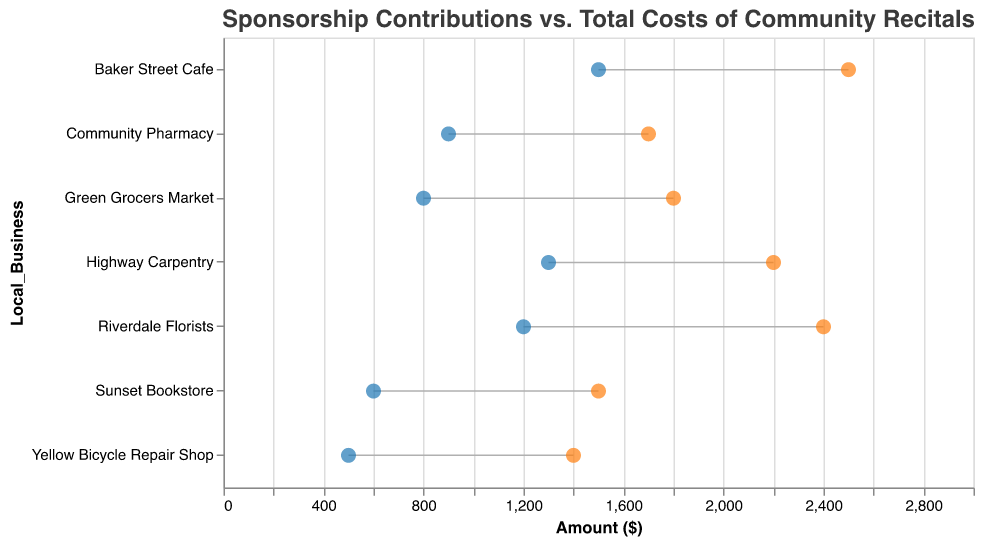What's the title of the figure? The title is displayed at the top of the plot to give an overview of what the plot represents. In this case, the title conveys information about the relationship between sponsorship contributions and total organizing costs for community recitals.
Answer: Sponsorship Contributions vs. Total Costs of Community Recitals Which local business has the highest sponsorship contribution? By looking at the dumbbell plot, we can identify the business with the highest position on the x-axis for sponsorship contributions. Baker Street Cafe has the highest contribution at $1500.
Answer: Baker Street Cafe Which local business has the smallest gap between sponsorship contribution and total cost of organizing? To find this, we look at the distance between the blue and orange circles (markers) for each local business. Riverdale Florists has the smallest gap, with a difference of $1200 and $2400, making the gap $1200.
Answer: Riverdale Florists What is the total cost of organizing recitals for the Community Pharmacy? The orange circle near "Community Pharmacy" shows its position on the x-axis for total costs. The value is $1700.
Answer: $1700 How much more is the total cost of organizing for Green Grocers Market compared to its sponsorship contribution? We need to subtract the sponsorship contribution from the total cost of organizing for Green Grocers Market. The values are $1800 and $800 respectively. The difference is $1800 - $800.
Answer: $1000 How many local businesses have a total cost of organizing less than $2000? We need to count the businesses where the orange circle (total cost) is positioned below the $2000 mark on the x-axis. There are 5 businesses: Community Pharmacy, Green Grocers Market, Yellow Bicycle Repair Shop, Sunset Bookstore, and Highway Carpentry.
Answer: 5 What is the average sponsorship contribution among all the businesses? We sum all the sponsorship contributions and divide by the number of businesses. The contributions are $1500, $1200, $800, $600, $500, $1300, and $900. The sum is $6800, divided by 7 businesses is $6800 / 7.
Answer: $971.43 Which business has the largest difference in sponsorship contribution vs. total cost of organizing? We need to calculate the difference for each business and find the maximum. The largest difference occurs for Baker Street Cafe ($2500 - $1500 = $1000).
Answer: Baker Street Cafe Is there any business whose sponsorship covers more than 50% of the total cost of organizing? We calculate the percentage by dividing the sponsorship contribution by the total cost for each business. Baker Street Cafe ($1500 / $2500 = 60%) and Riverdale Florists ($1200 / $2400 = 50%) both meet this criterion.
Answer: Yes, Baker Street Cafe and Riverdale Florists 